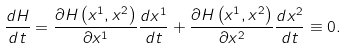Convert formula to latex. <formula><loc_0><loc_0><loc_500><loc_500>\frac { d H } { d t } = \frac { \partial H \left ( x ^ { 1 } , x ^ { 2 } \right ) } { \partial x ^ { 1 } } \frac { d x ^ { 1 } } { d t } + \frac { \partial H \left ( x ^ { 1 } , x ^ { 2 } \right ) } { \partial x ^ { 2 } } \frac { d x ^ { 2 } } { d t } \equiv 0 .</formula> 